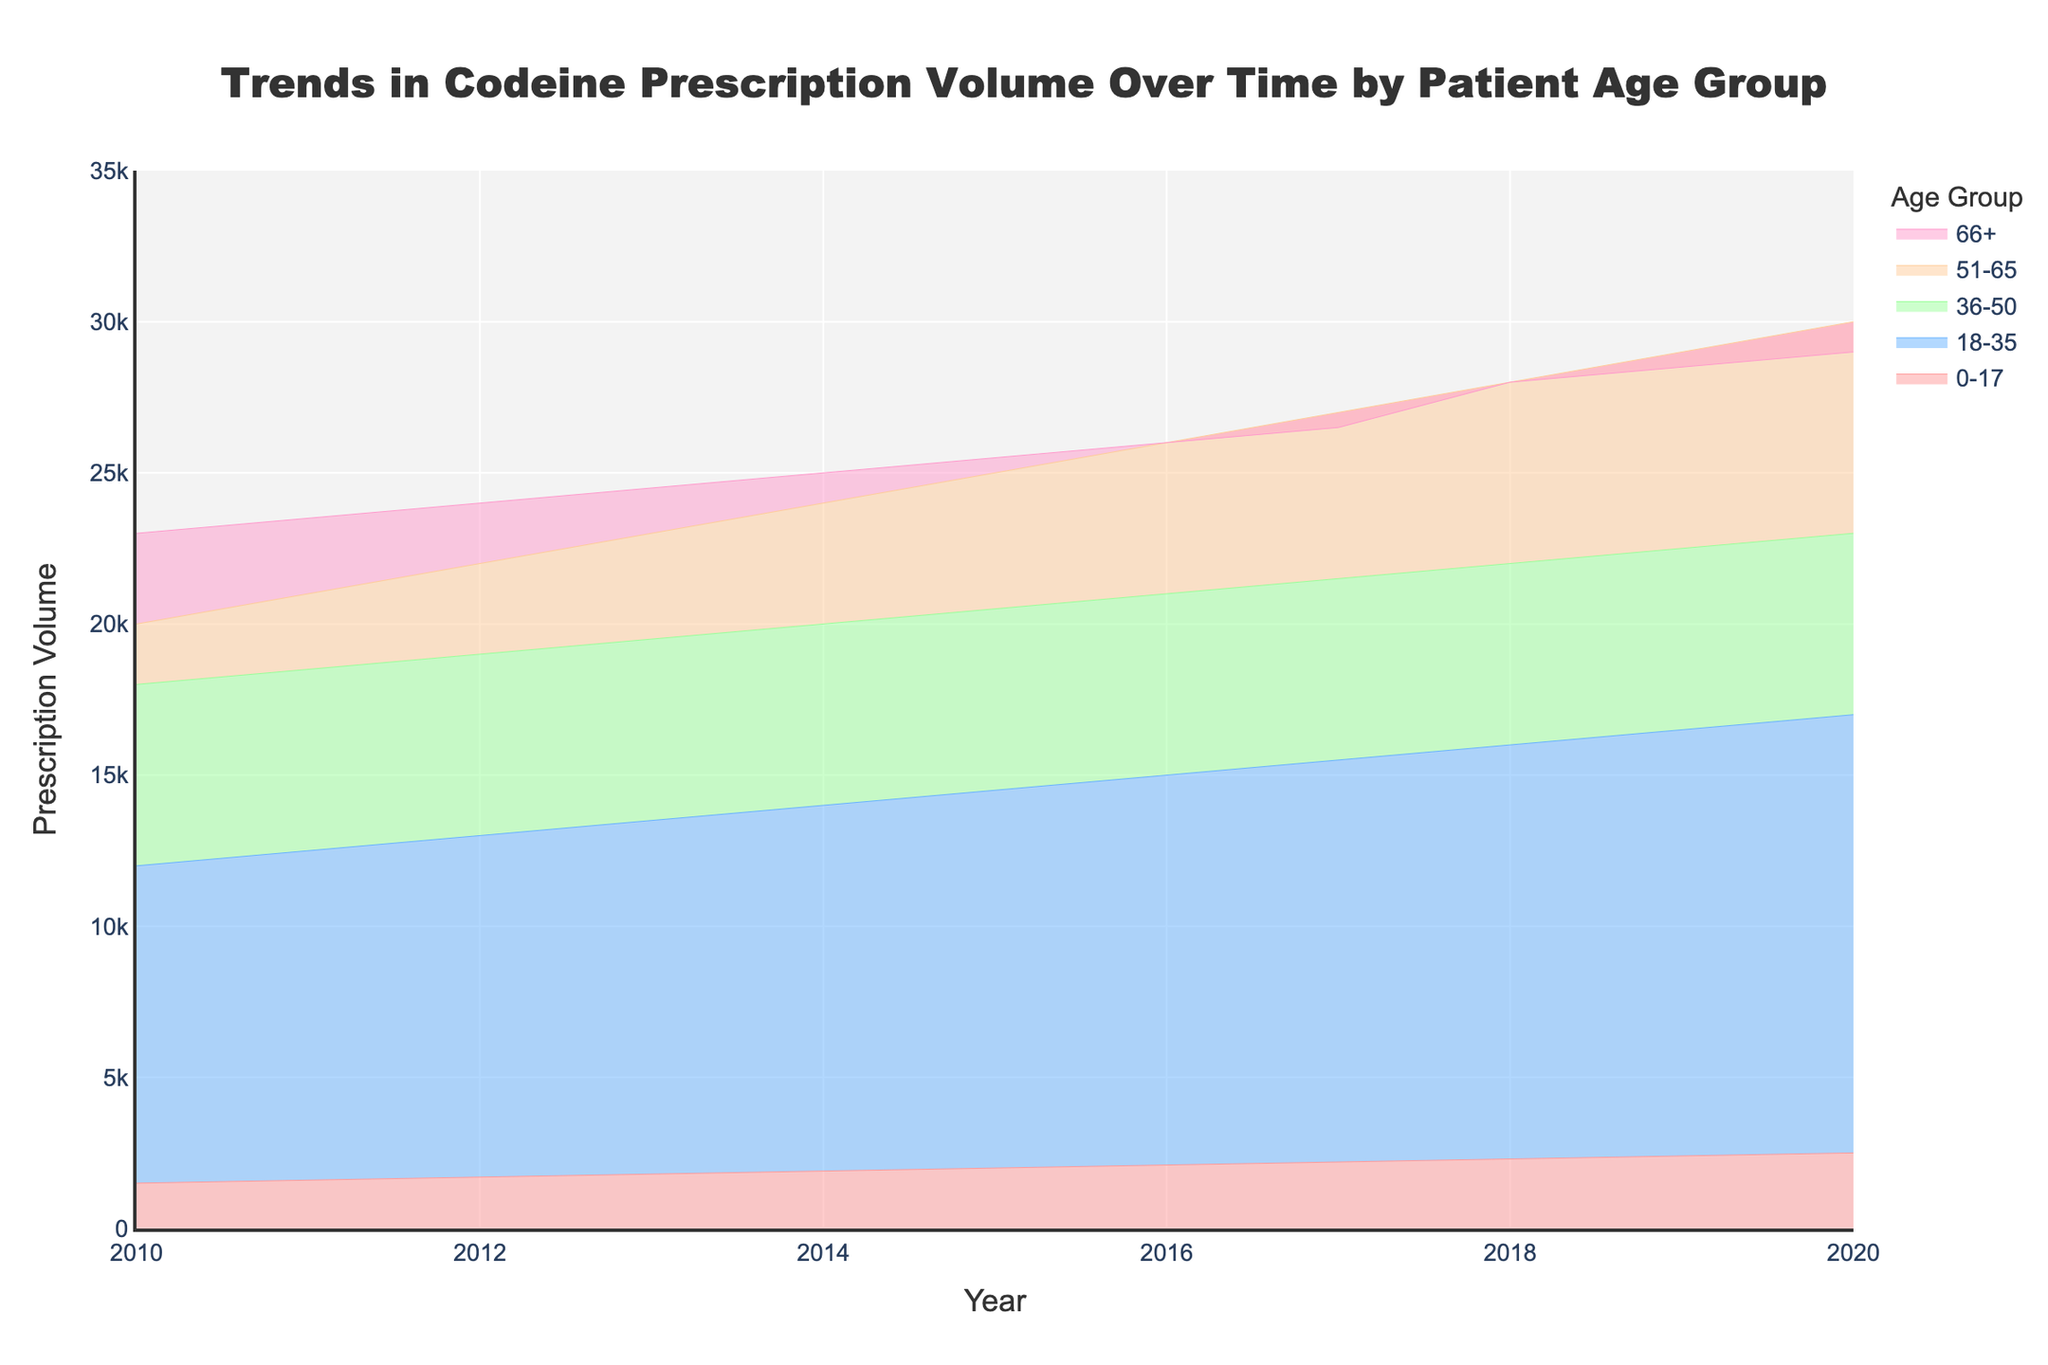What is the title of the figure? The title of the figure is displayed at the top of the chart. It helps to understand what the figure represents. The title of this figure is: "Trends in Codeine Prescription Volume Over Time by Patient Age Group".
Answer: Trends in Codeine Prescription Volume Over Time by Patient Age Group Which age group consistently had the highest prescription volume from 2010 to 2020? By looking at the areas of different colors, we can see that the age group 66+ has the largest area for all years, indicating the highest prescription volume.
Answer: 66+ What is the difference in prescription volume for the age group 18-35 between the years 2010 and 2020? By checking the chart, the prescription volume in 2010 is 12000, and in 2020 it's 17000. The difference is calculated as 17000 - 12000.
Answer: 5000 In which year did the prescription volume for the age group 51-65 first exceed 25000? By examining the area chart for the age group 51-65, we see that the prescription volume first exceeds 25000 in the year 2016.
Answer: 2016 How has the total prescription volume across all age groups changed from 2010 to 2020? Summing the prescription volumes for all age groups in 2010 and comparing it to the sum for 2020, we get: (1500 + 12000 + 18000 + 20000 + 23000) for 2010 and (2500 + 17000 + 23000 + 30000 + 29000) for 2020. The difference is (2500 + 17000 + 23000 + 30000 + 29000) - (1500 + 12000 + 18000 + 20000 + 23000).
Answer: 17500 Which age group has shown the most significant increase in prescription volume from 2010 to 2020? For each age group, calculate the difference between the prescription volumes in 2010 and 2020, then compare these differences. The differences are: 
0-17: 2500 - 1500 = 1000, 
18-35: 17000 - 12000 = 5000, 
36-50: 23000 - 18000 = 5000, 
51-65: 30000 - 20000 = 10000, 
66+: 29000 - 23000 = 6000. Thus, the age group 51-65 shows the most significant increase.
Answer: 51-65 What is the average prescription volume for the age group 36-50 over the entire period? Sum all the prescription volumes for the age group 36-50 over the 11 years and divide by the number of years. The volumes are 18000, 18500, 19000, 19500, 20000, 20500, 21000, 21500, 22000, 22500, 23000. The average is calculated as (18000 + 18500 + 19000 + 19500 + 20000 + 20500 + 21000 + 21500 + 22000 + 22500 + 23000) / 11.
Answer: 20363.64 